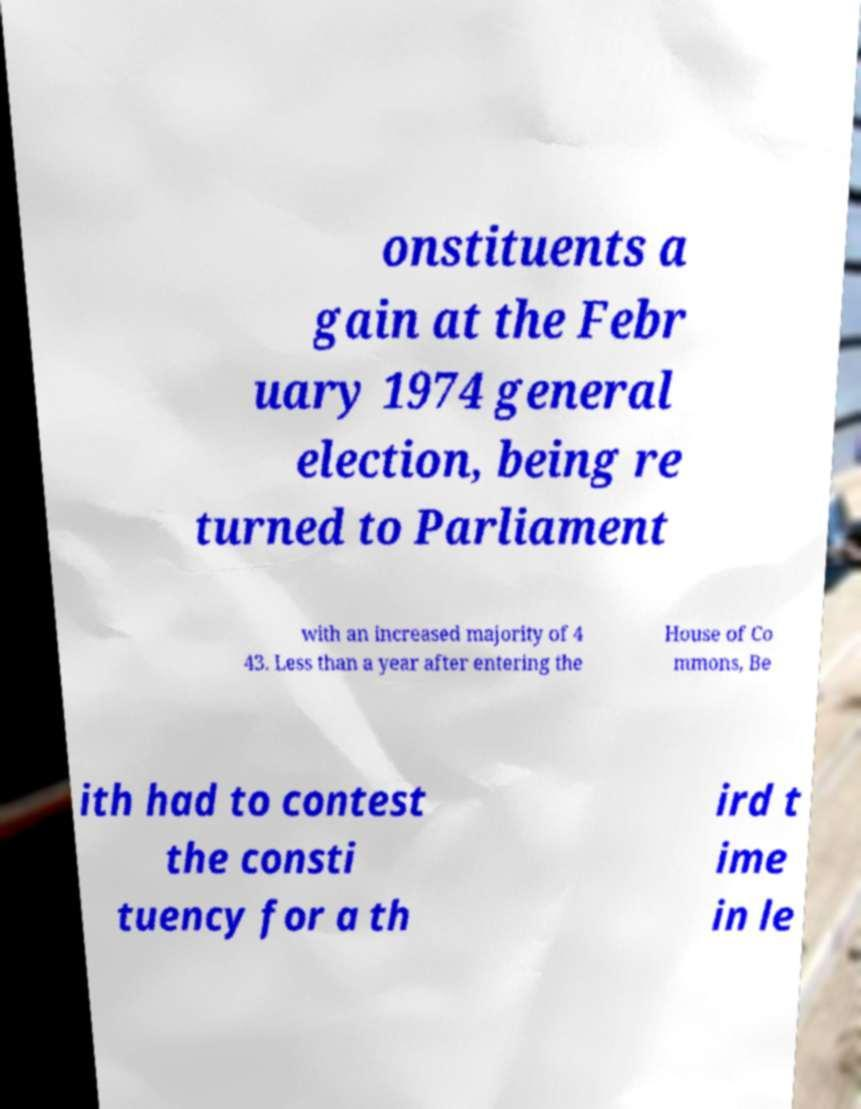I need the written content from this picture converted into text. Can you do that? onstituents a gain at the Febr uary 1974 general election, being re turned to Parliament with an increased majority of 4 43. Less than a year after entering the House of Co mmons, Be ith had to contest the consti tuency for a th ird t ime in le 